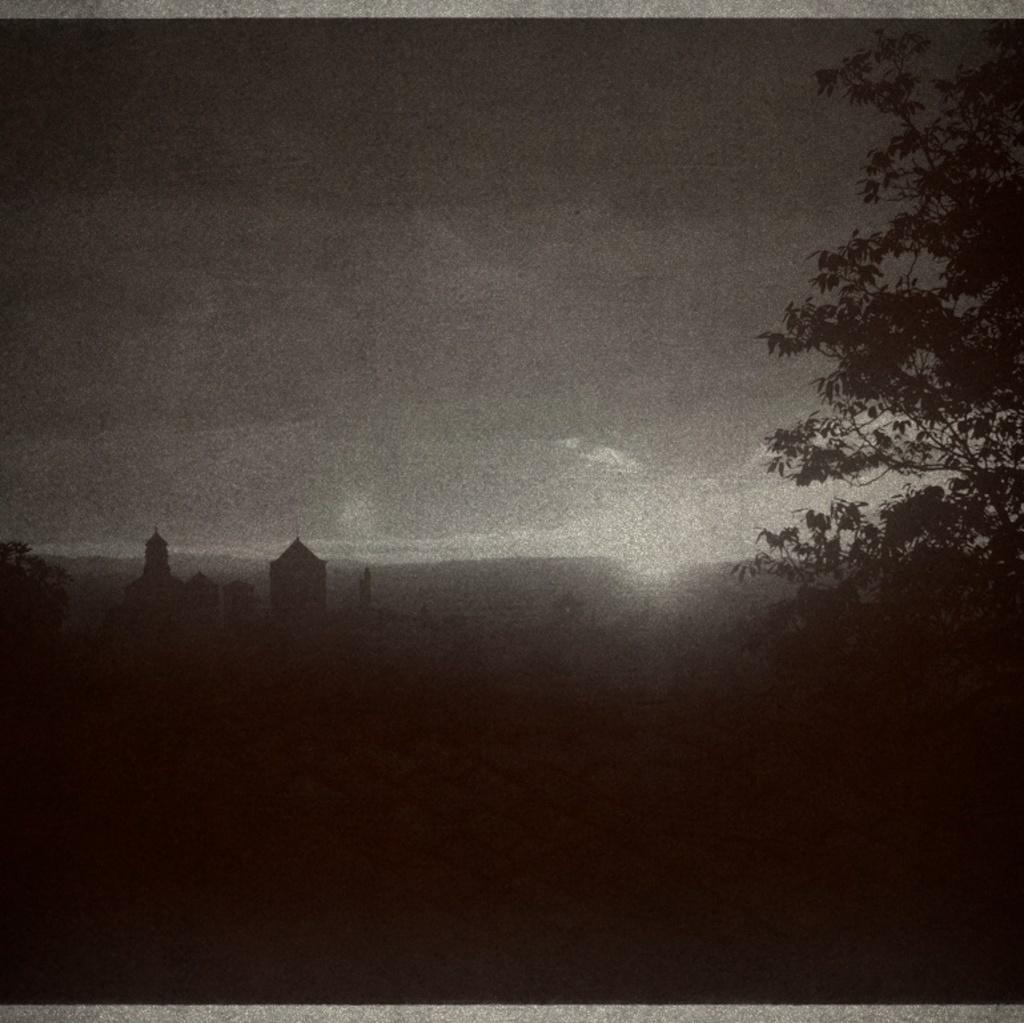What is the main object in the foreground of the image? There is a tree in the image. What can be seen in the background of the image? There are buildings behind the tree. How would you describe the weather based on the image? The sky is clear, which suggests good weather. What color scheme is used in the image? The image is in black and white color. Can you see any mist around the tree in the image? No, there is no mist visible in the image. Are people walking around the tree in the image? There is no indication of people or walking in the image. 